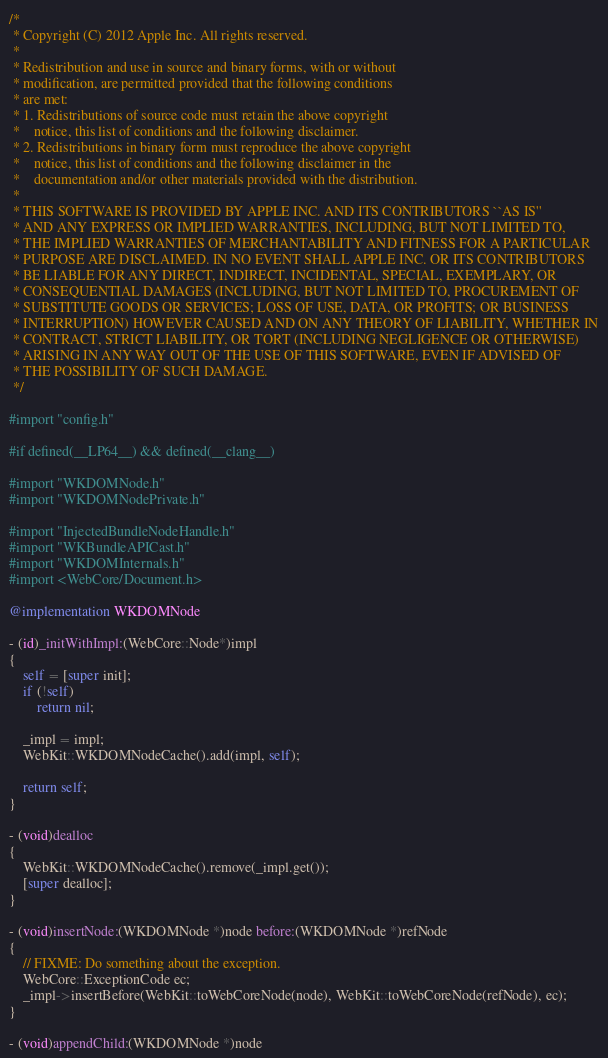<code> <loc_0><loc_0><loc_500><loc_500><_ObjectiveC_>/*
 * Copyright (C) 2012 Apple Inc. All rights reserved.
 *
 * Redistribution and use in source and binary forms, with or without
 * modification, are permitted provided that the following conditions
 * are met:
 * 1. Redistributions of source code must retain the above copyright
 *    notice, this list of conditions and the following disclaimer.
 * 2. Redistributions in binary form must reproduce the above copyright
 *    notice, this list of conditions and the following disclaimer in the
 *    documentation and/or other materials provided with the distribution.
 *
 * THIS SOFTWARE IS PROVIDED BY APPLE INC. AND ITS CONTRIBUTORS ``AS IS''
 * AND ANY EXPRESS OR IMPLIED WARRANTIES, INCLUDING, BUT NOT LIMITED TO,
 * THE IMPLIED WARRANTIES OF MERCHANTABILITY AND FITNESS FOR A PARTICULAR
 * PURPOSE ARE DISCLAIMED. IN NO EVENT SHALL APPLE INC. OR ITS CONTRIBUTORS
 * BE LIABLE FOR ANY DIRECT, INDIRECT, INCIDENTAL, SPECIAL, EXEMPLARY, OR
 * CONSEQUENTIAL DAMAGES (INCLUDING, BUT NOT LIMITED TO, PROCUREMENT OF
 * SUBSTITUTE GOODS OR SERVICES; LOSS OF USE, DATA, OR PROFITS; OR BUSINESS
 * INTERRUPTION) HOWEVER CAUSED AND ON ANY THEORY OF LIABILITY, WHETHER IN
 * CONTRACT, STRICT LIABILITY, OR TORT (INCLUDING NEGLIGENCE OR OTHERWISE)
 * ARISING IN ANY WAY OUT OF THE USE OF THIS SOFTWARE, EVEN IF ADVISED OF
 * THE POSSIBILITY OF SUCH DAMAGE.
 */

#import "config.h"

#if defined(__LP64__) && defined(__clang__)

#import "WKDOMNode.h"
#import "WKDOMNodePrivate.h"

#import "InjectedBundleNodeHandle.h"
#import "WKBundleAPICast.h"
#import "WKDOMInternals.h"
#import <WebCore/Document.h>

@implementation WKDOMNode

- (id)_initWithImpl:(WebCore::Node*)impl
{
    self = [super init];
    if (!self)
        return nil;

    _impl = impl;
    WebKit::WKDOMNodeCache().add(impl, self);

    return self;
}

- (void)dealloc
{
    WebKit::WKDOMNodeCache().remove(_impl.get());
    [super dealloc];
}

- (void)insertNode:(WKDOMNode *)node before:(WKDOMNode *)refNode
{
    // FIXME: Do something about the exception.
    WebCore::ExceptionCode ec;
    _impl->insertBefore(WebKit::toWebCoreNode(node), WebKit::toWebCoreNode(refNode), ec);
}

- (void)appendChild:(WKDOMNode *)node</code> 